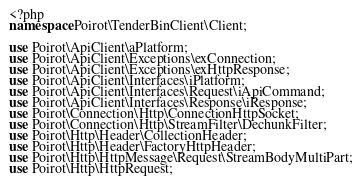<code> <loc_0><loc_0><loc_500><loc_500><_PHP_><?php
namespace Poirot\TenderBinClient\Client;

use Poirot\ApiClient\aPlatform;
use Poirot\ApiClient\Exceptions\exConnection;
use Poirot\ApiClient\Exceptions\exHttpResponse;
use Poirot\ApiClient\Interfaces\iPlatform;
use Poirot\ApiClient\Interfaces\Request\iApiCommand;
use Poirot\ApiClient\Interfaces\Response\iResponse;
use Poirot\Connection\Http\ConnectionHttpSocket;
use Poirot\Connection\Http\StreamFilter\DechunkFilter;
use Poirot\Http\Header\CollectionHeader;
use Poirot\Http\Header\FactoryHttpHeader;
use Poirot\Http\HttpMessage\Request\StreamBodyMultiPart;
use Poirot\Http\HttpRequest;</code> 